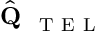<formula> <loc_0><loc_0><loc_500><loc_500>\hat { Q } _ { T E L }</formula> 